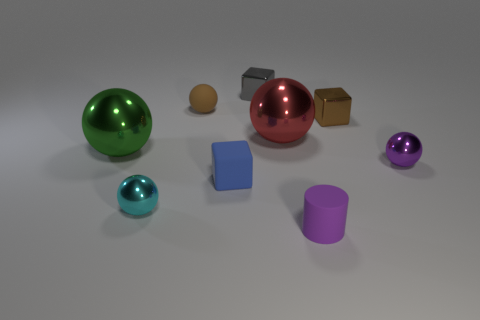Subtract all green spheres. How many spheres are left? 4 Subtract all purple shiny balls. How many balls are left? 4 Subtract 2 spheres. How many spheres are left? 3 Subtract all blue balls. Subtract all yellow cylinders. How many balls are left? 5 Add 1 big cyan rubber cubes. How many objects exist? 10 Subtract all cubes. How many objects are left? 6 Subtract all large red things. Subtract all big blue cylinders. How many objects are left? 8 Add 8 small gray metallic blocks. How many small gray metallic blocks are left? 9 Add 6 blue matte cubes. How many blue matte cubes exist? 7 Subtract 1 brown balls. How many objects are left? 8 